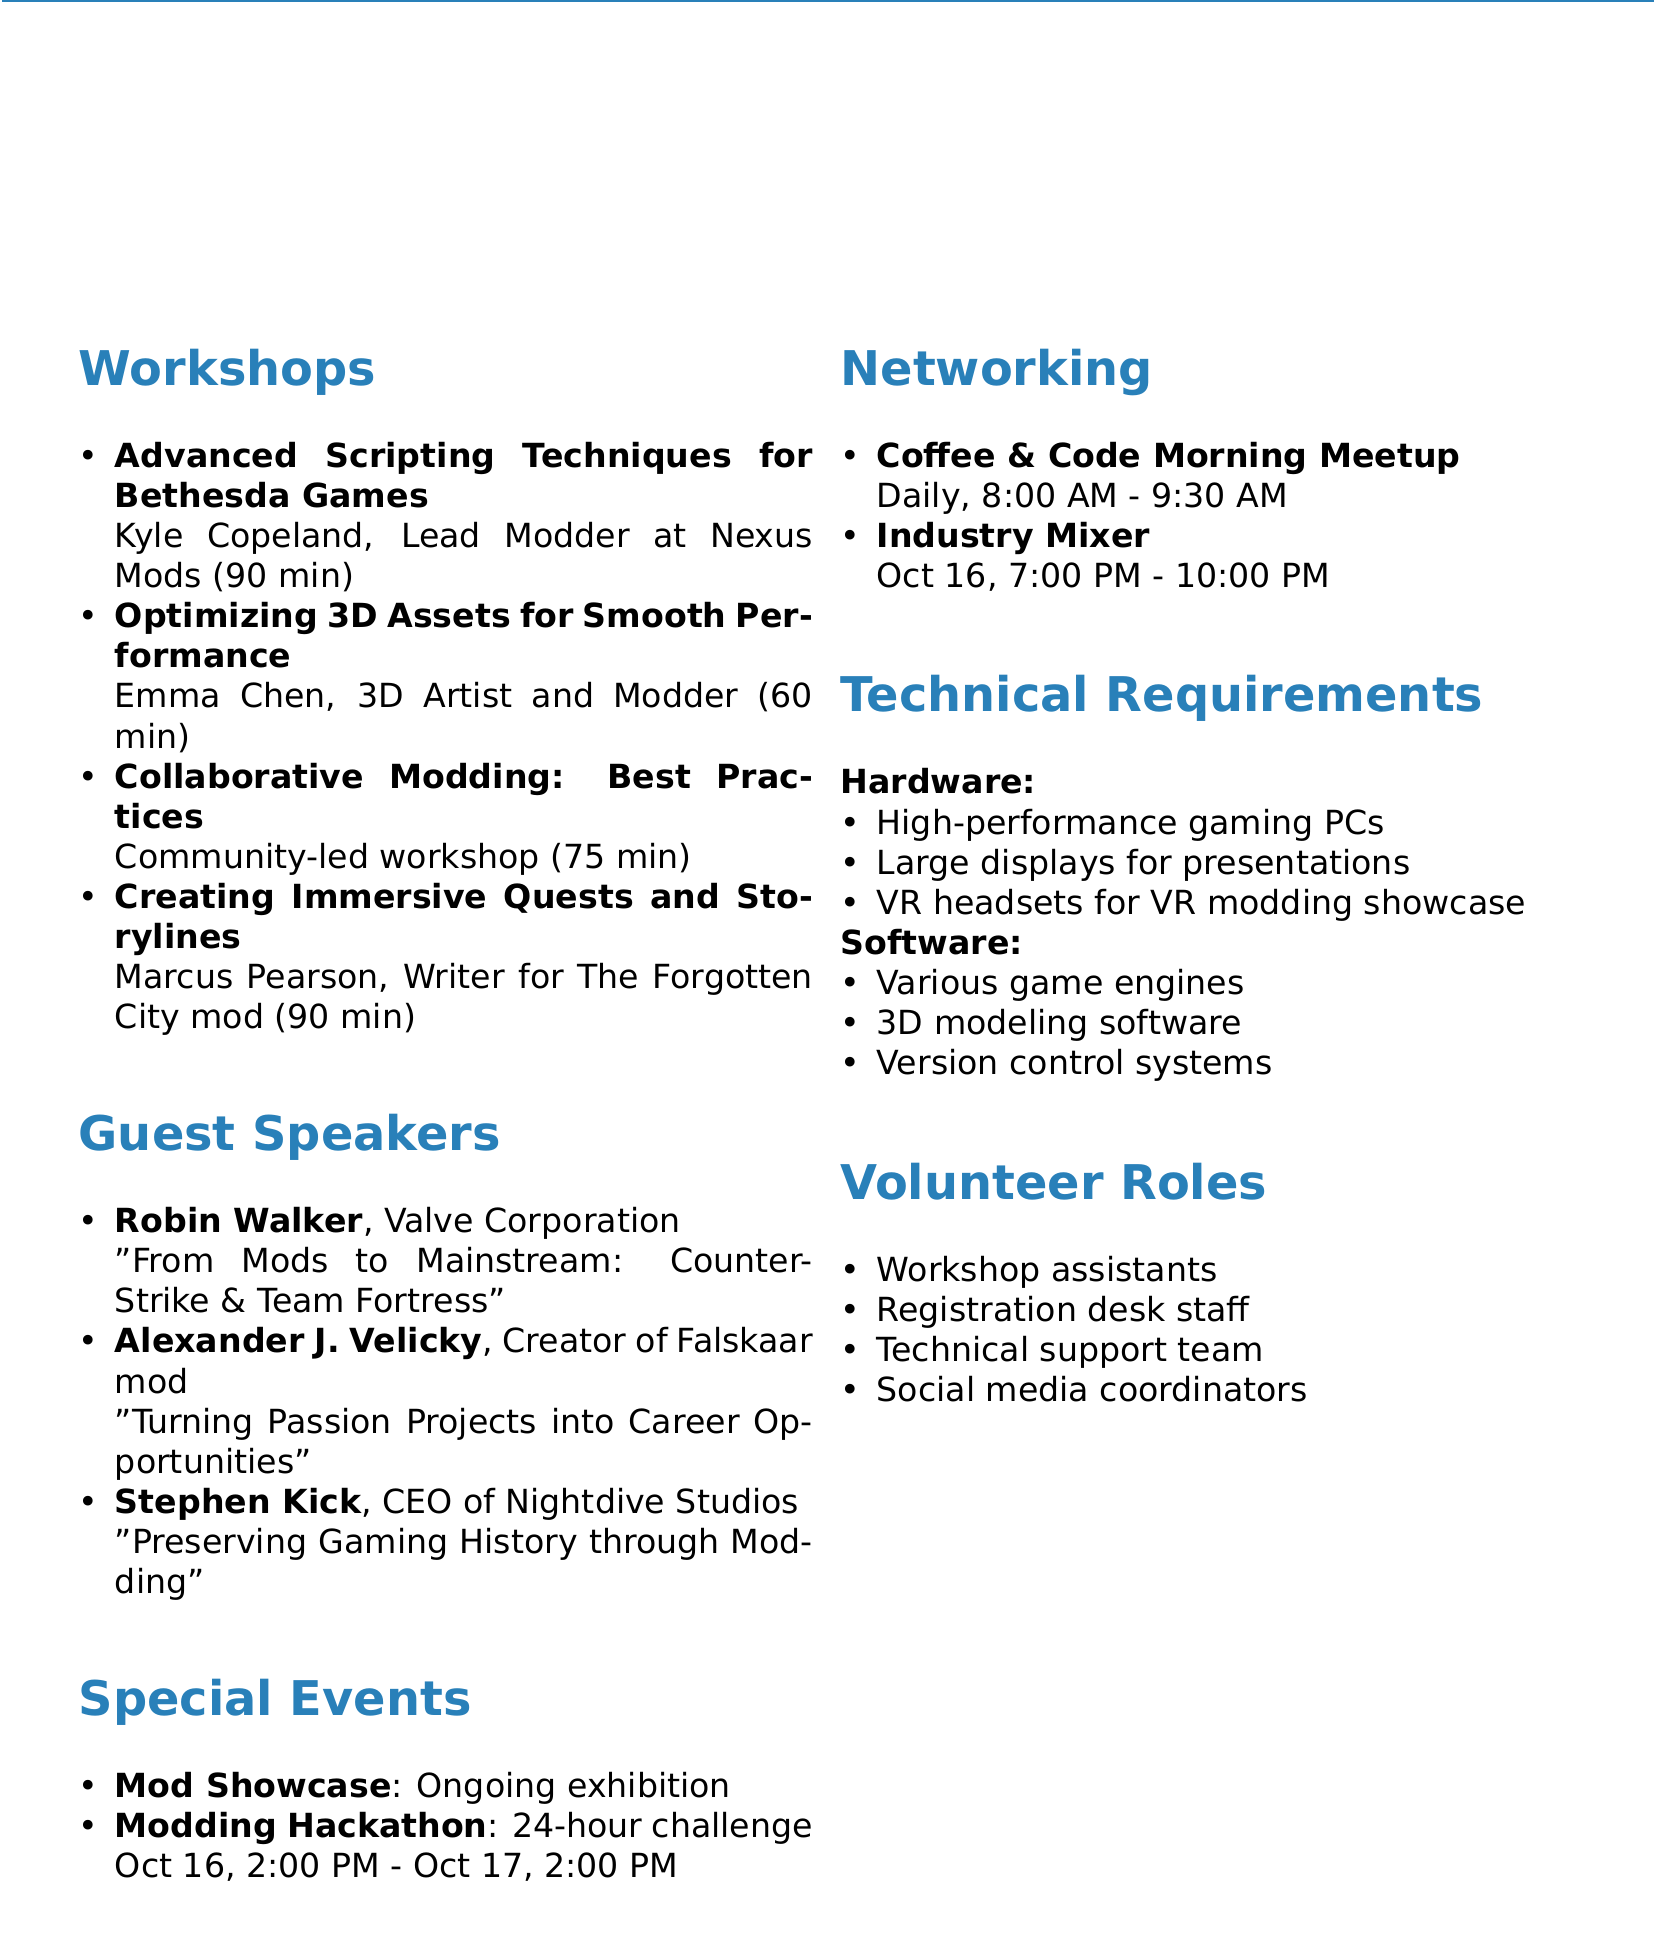What is the event name? The event name is explicitly stated in the document as ModCon 2023.
Answer: ModCon 2023 When is the event scheduled? The event date is mentioned directly in the document, indicating it takes place on October 15-17, 2023.
Answer: October 15-17, 2023 Who is presenting the workshop on optimizing 3D assets? The presenter's name is provided in the workshop topics section of the document.
Answer: Emma Chen What is the duration of the "Creating Immersive Quests and Storylines" workshop? The document provides the duration of each workshop, including this specific workshop, which is 90 minutes.
Answer: 90 minutes How many guest speakers are listed in the document? The number of guest speakers can be counted in the guest speaker suggestions section, which lists three speakers.
Answer: 3 What is the name of the special event occurring continuously throughout the event? The name is detailed under special events, specifying ongoing activities in the exhibition area.
Answer: Mod Showcase What topic will Robin Walker discuss? The topic is included in the guest speaker section and specifies what Robin Walker will be presenting about.
Answer: From Mods to Mainstream: The Evolution of Counter-Strike and Team Fortress What time does the Industry Mixer start? The starting time is directly mentioned in the networking opportunities section of the document.
Answer: 7:00 PM What roles are mentioned for volunteers? The document lists several roles for volunteers that indicate opportunities for participation in the event.
Answer: Workshop assistants, Registration desk staff, Technical support team, Social media coordinators 